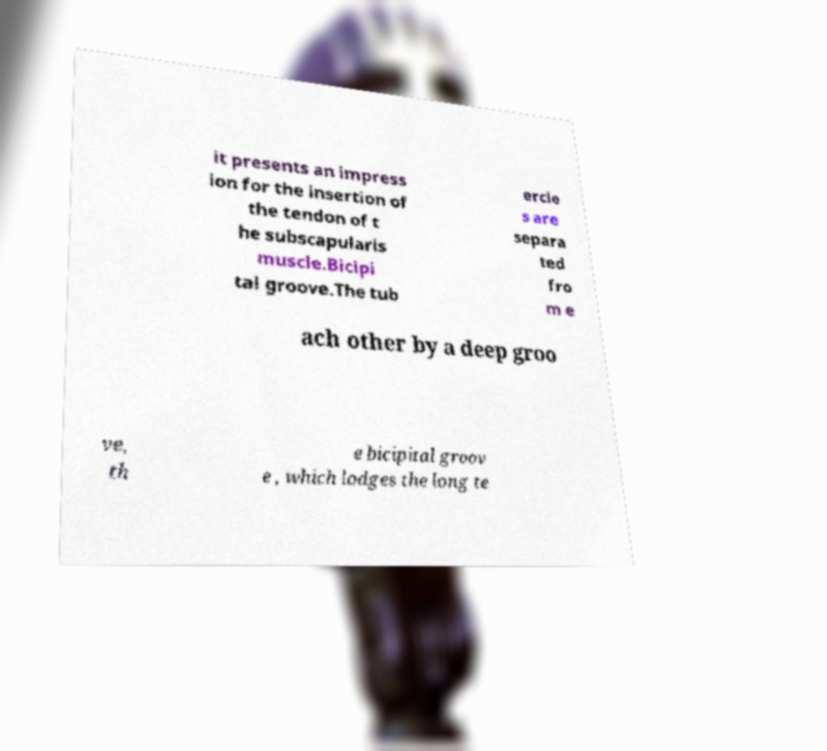For documentation purposes, I need the text within this image transcribed. Could you provide that? it presents an impress ion for the insertion of the tendon of t he subscapularis muscle.Bicipi tal groove.The tub ercle s are separa ted fro m e ach other by a deep groo ve, th e bicipital groov e , which lodges the long te 